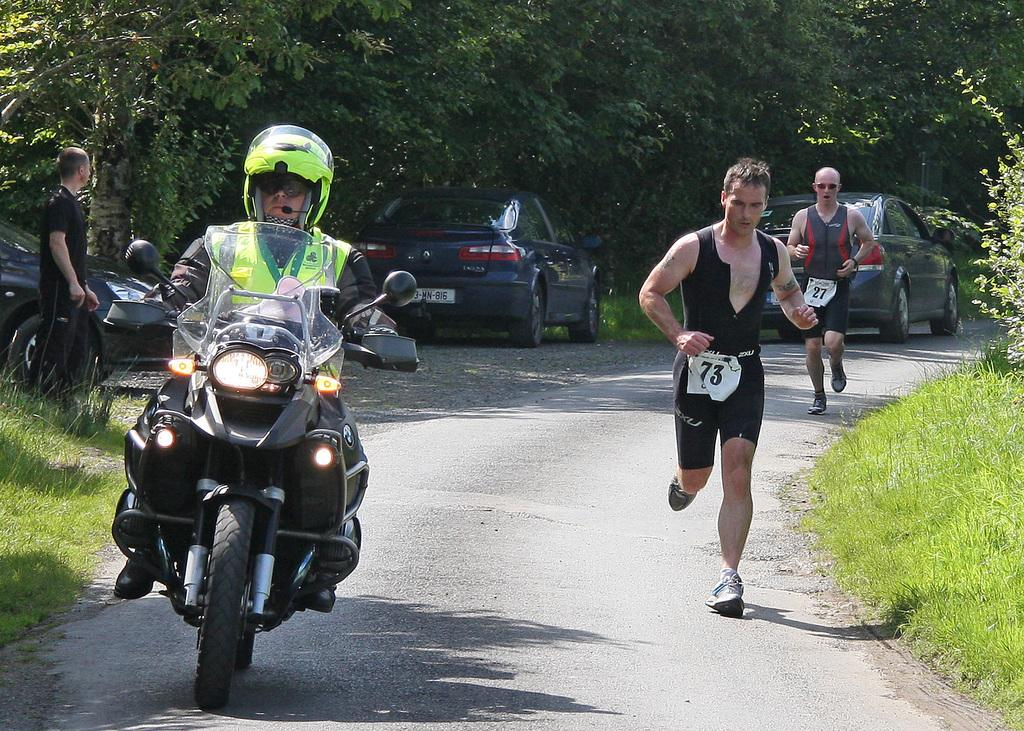What is the man in the image doing? The man is riding a two-wheeler in the image. What are the other people in the image doing? Two persons are running in the image. Can you describe any vehicles in the image? There is a parked car in the image. What can be seen in the background of the image? Trees are visible in the background of the image. What type of marble can be seen on the seashore in the image? There is no marble or seashore present in the image. How many people are smiling in the image? The provided facts do not mention anyone smiling in the image. 